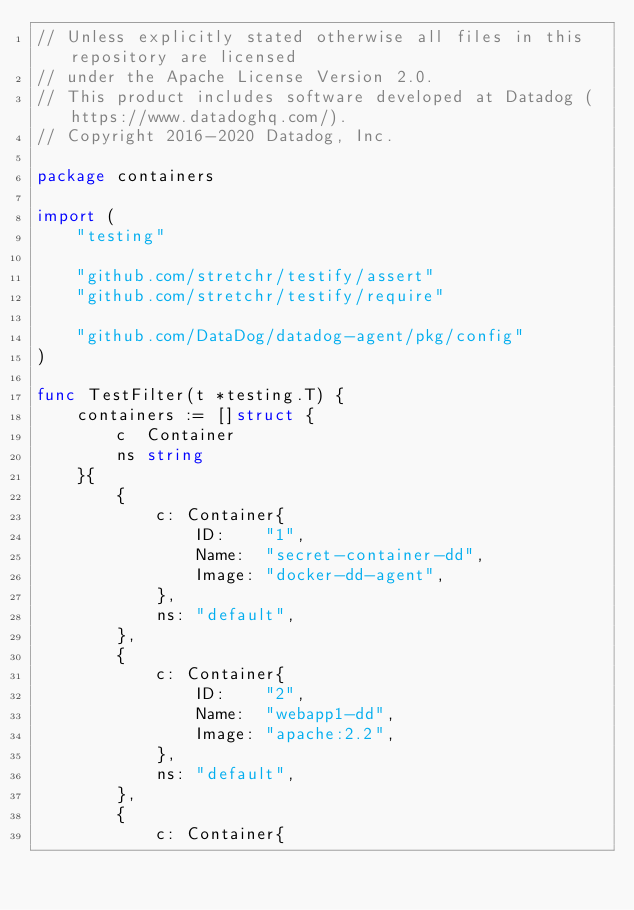Convert code to text. <code><loc_0><loc_0><loc_500><loc_500><_Go_>// Unless explicitly stated otherwise all files in this repository are licensed
// under the Apache License Version 2.0.
// This product includes software developed at Datadog (https://www.datadoghq.com/).
// Copyright 2016-2020 Datadog, Inc.

package containers

import (
	"testing"

	"github.com/stretchr/testify/assert"
	"github.com/stretchr/testify/require"

	"github.com/DataDog/datadog-agent/pkg/config"
)

func TestFilter(t *testing.T) {
	containers := []struct {
		c  Container
		ns string
	}{
		{
			c: Container{
				ID:    "1",
				Name:  "secret-container-dd",
				Image: "docker-dd-agent",
			},
			ns: "default",
		},
		{
			c: Container{
				ID:    "2",
				Name:  "webapp1-dd",
				Image: "apache:2.2",
			},
			ns: "default",
		},
		{
			c: Container{</code> 